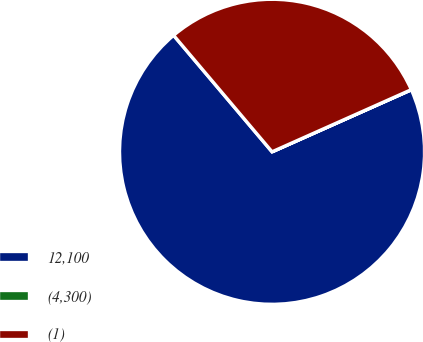Convert chart to OTSL. <chart><loc_0><loc_0><loc_500><loc_500><pie_chart><fcel>12,100<fcel>(4,300)<fcel>(1)<nl><fcel>70.51%<fcel>0.01%<fcel>29.49%<nl></chart> 